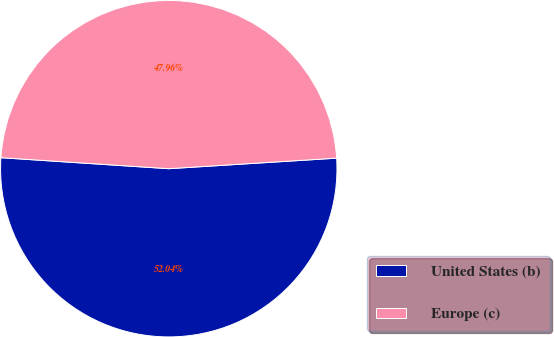Convert chart to OTSL. <chart><loc_0><loc_0><loc_500><loc_500><pie_chart><fcel>United States (b)<fcel>Europe (c)<nl><fcel>52.04%<fcel>47.96%<nl></chart> 